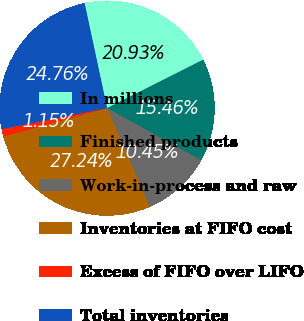Convert chart to OTSL. <chart><loc_0><loc_0><loc_500><loc_500><pie_chart><fcel>In millions<fcel>Finished products<fcel>Work-in-process and raw<fcel>Inventories at FIFO cost<fcel>Excess of FIFO over LIFO<fcel>Total inventories<nl><fcel>20.93%<fcel>15.46%<fcel>10.45%<fcel>27.24%<fcel>1.15%<fcel>24.76%<nl></chart> 